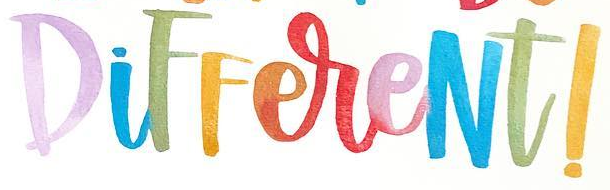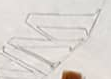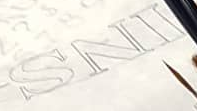What words can you see in these images in sequence, separated by a semicolon? DiFFereNt!; W; INS 